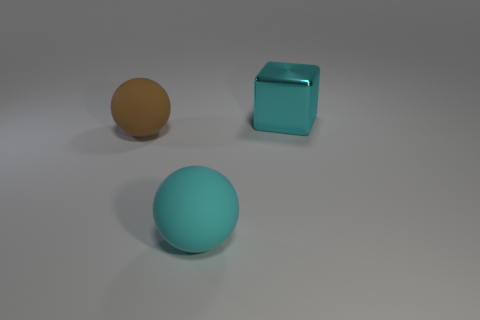Is there anything else that is the same shape as the brown rubber object?
Your response must be concise. Yes. Are any cyan metallic things visible?
Ensure brevity in your answer.  Yes. Are there fewer things than large metallic blocks?
Ensure brevity in your answer.  No. What number of big brown balls are made of the same material as the big cyan block?
Ensure brevity in your answer.  0. There is a big thing that is the same material as the cyan ball; what color is it?
Offer a very short reply. Brown. The large cyan metal thing is what shape?
Provide a short and direct response. Cube. What number of other large metallic cubes are the same color as the big metal block?
Provide a short and direct response. 0. There is a cyan rubber thing that is the same size as the brown ball; what is its shape?
Provide a succinct answer. Sphere. Are there any blue matte things that have the same size as the cyan matte sphere?
Your answer should be compact. No. There is a cyan ball that is the same size as the cyan cube; what is it made of?
Keep it short and to the point. Rubber. 